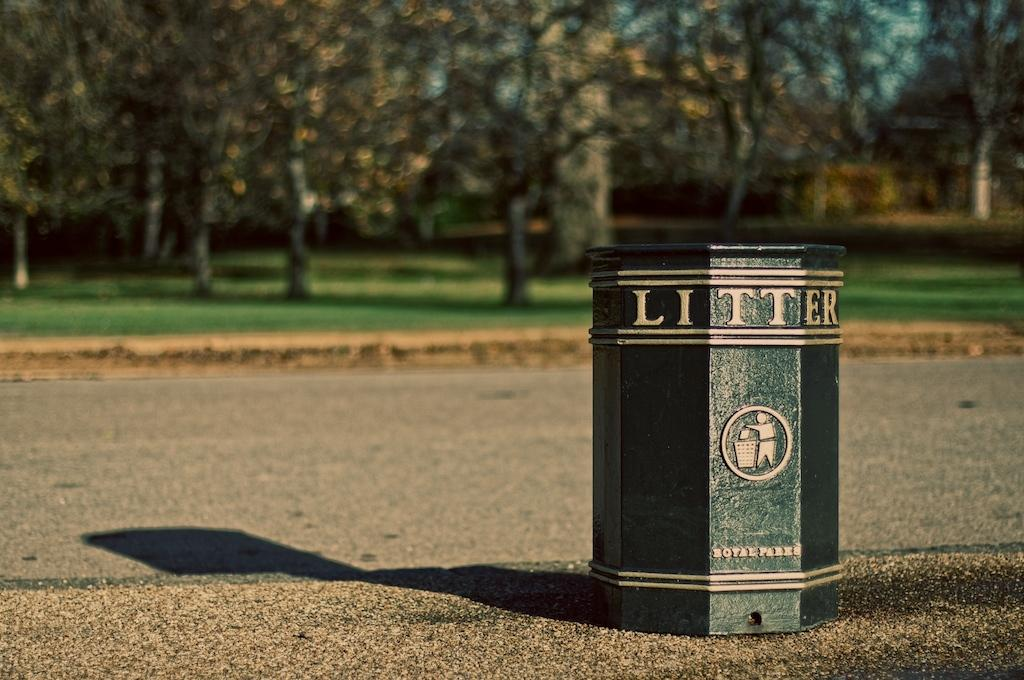<image>
Offer a succinct explanation of the picture presented. A trash can in the park is printed with the work LITTER at the top. 